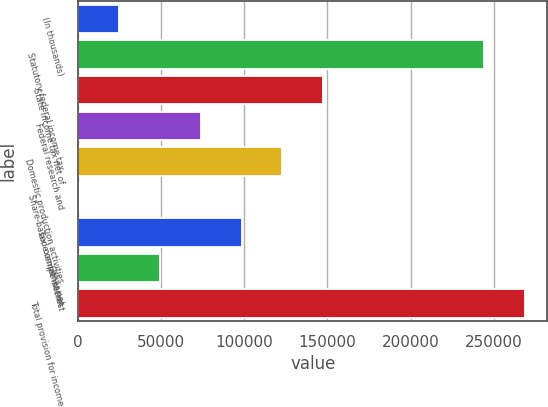Convert chart. <chart><loc_0><loc_0><loc_500><loc_500><bar_chart><fcel>(In thousands)<fcel>Statutory federal income tax<fcel>State income tax net of<fcel>Federal research and<fcel>Domestic production activities<fcel>Share-based compensation<fcel>Tax exempt interest<fcel>Other net<fcel>Total provision for income<nl><fcel>24837.8<fcel>244294<fcel>147472<fcel>73891.4<fcel>122945<fcel>311<fcel>98418.2<fcel>49364.6<fcel>268821<nl></chart> 